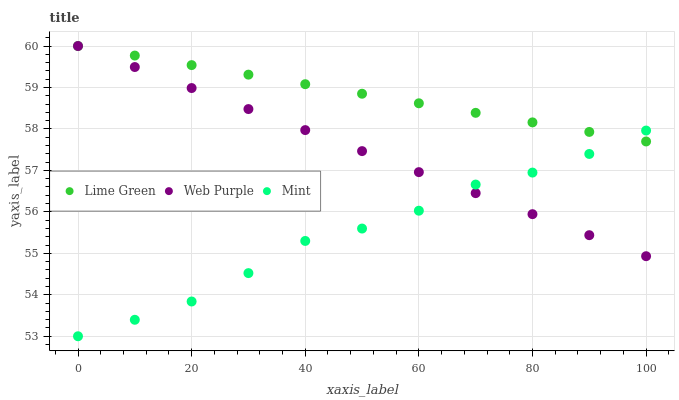Does Mint have the minimum area under the curve?
Answer yes or no. Yes. Does Lime Green have the maximum area under the curve?
Answer yes or no. Yes. Does Web Purple have the minimum area under the curve?
Answer yes or no. No. Does Web Purple have the maximum area under the curve?
Answer yes or no. No. Is Lime Green the smoothest?
Answer yes or no. Yes. Is Mint the roughest?
Answer yes or no. Yes. Is Web Purple the smoothest?
Answer yes or no. No. Is Web Purple the roughest?
Answer yes or no. No. Does Mint have the lowest value?
Answer yes or no. Yes. Does Web Purple have the lowest value?
Answer yes or no. No. Does Lime Green have the highest value?
Answer yes or no. Yes. Does Mint intersect Lime Green?
Answer yes or no. Yes. Is Mint less than Lime Green?
Answer yes or no. No. Is Mint greater than Lime Green?
Answer yes or no. No. 